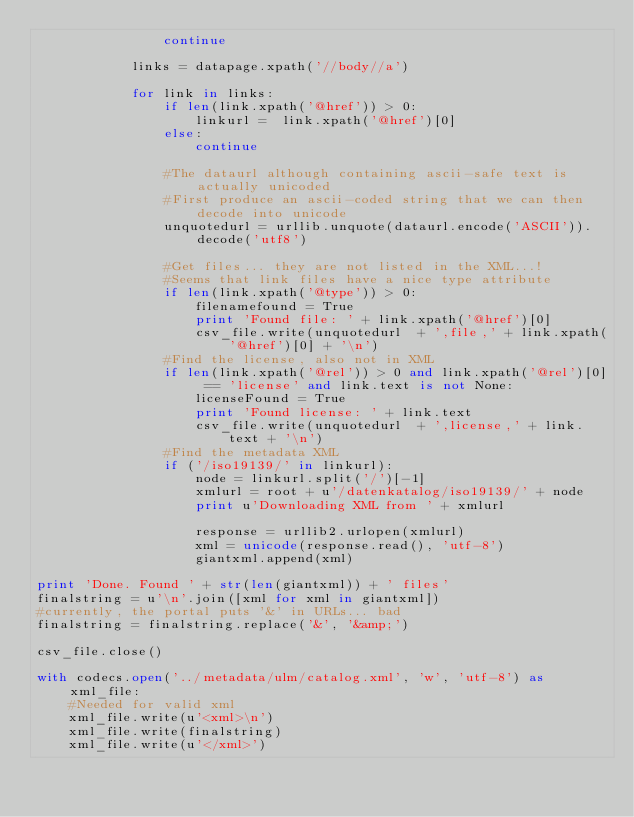<code> <loc_0><loc_0><loc_500><loc_500><_Python_>                continue
                
            links = datapage.xpath('//body//a')
            
            for link in links:
                if len(link.xpath('@href')) > 0:
                    linkurl =  link.xpath('@href')[0]
                else:
                    continue

                #The dataurl although containing ascii-safe text is actually unicoded
                #First produce an ascii-coded string that we can then decode into unicode
                unquotedurl = urllib.unquote(dataurl.encode('ASCII')).decode('utf8')
                
                #Get files... they are not listed in the XML...!
                #Seems that link files have a nice type attribute
                if len(link.xpath('@type')) > 0:
                    filenamefound = True
                    print 'Found file: ' + link.xpath('@href')[0]
                    csv_file.write(unquotedurl  + ',file,' + link.xpath('@href')[0] + '\n')
                #Find the license, also not in XML  
                if len(link.xpath('@rel')) > 0 and link.xpath('@rel')[0] == 'license' and link.text is not None:
                    licenseFound = True
                    print 'Found license: ' + link.text
                    csv_file.write(unquotedurl  + ',license,' + link.text + '\n')
                #Find the metadata XML    
                if ('/iso19139/' in linkurl):
                    node = linkurl.split('/')[-1]
                    xmlurl = root + u'/datenkatalog/iso19139/' + node
                    print u'Downloading XML from ' + xmlurl
                    
                    response = urllib2.urlopen(xmlurl)
                    xml = unicode(response.read(), 'utf-8')
                    giantxml.append(xml)
    
print 'Done. Found ' + str(len(giantxml)) + ' files'
finalstring = u'\n'.join([xml for xml in giantxml])
#currently, the portal puts '&' in URLs... bad
finalstring = finalstring.replace('&', '&amp;')

csv_file.close()

with codecs.open('../metadata/ulm/catalog.xml', 'w', 'utf-8') as xml_file:
    #Needed for valid xml
    xml_file.write(u'<xml>\n')
    xml_file.write(finalstring)
    xml_file.write(u'</xml>')
</code> 